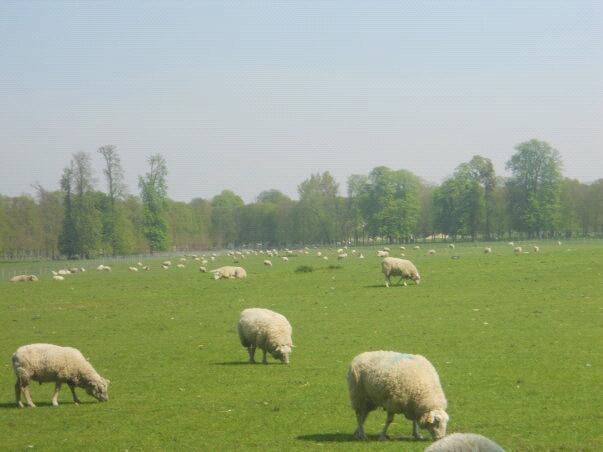How many sheep are there?
Give a very brief answer. 3. 